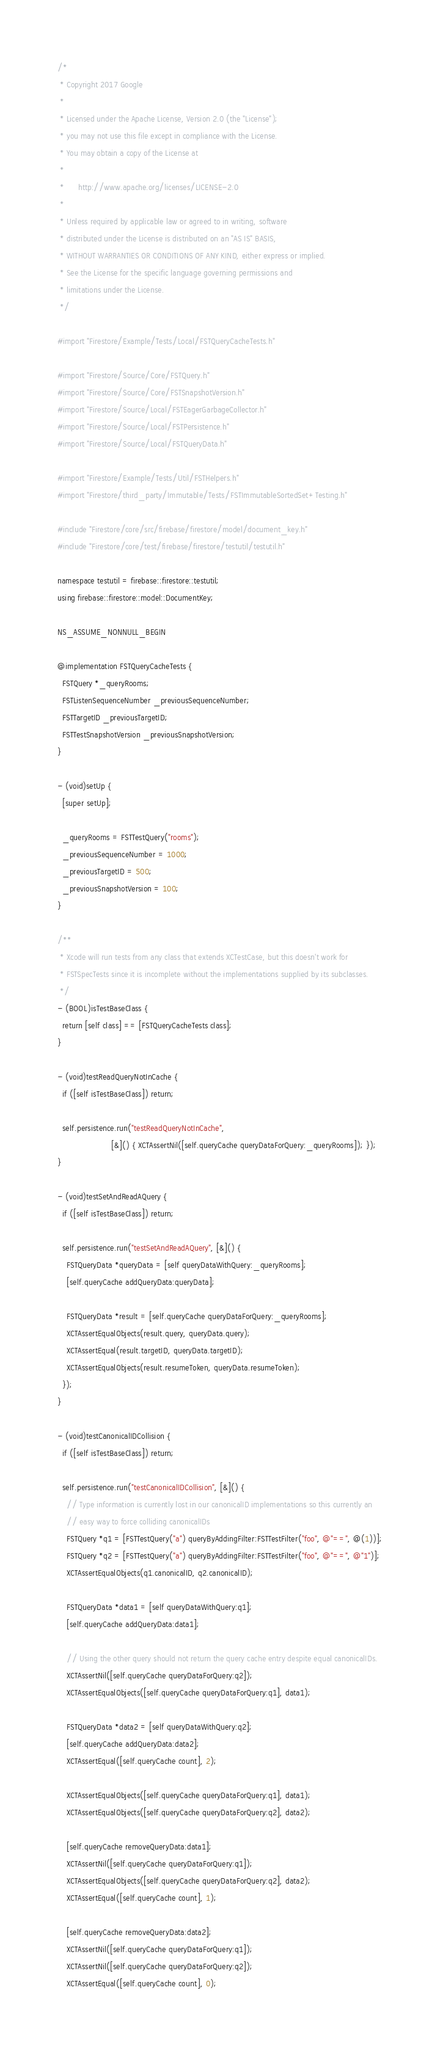Convert code to text. <code><loc_0><loc_0><loc_500><loc_500><_ObjectiveC_>/*
 * Copyright 2017 Google
 *
 * Licensed under the Apache License, Version 2.0 (the "License");
 * you may not use this file except in compliance with the License.
 * You may obtain a copy of the License at
 *
 *      http://www.apache.org/licenses/LICENSE-2.0
 *
 * Unless required by applicable law or agreed to in writing, software
 * distributed under the License is distributed on an "AS IS" BASIS,
 * WITHOUT WARRANTIES OR CONDITIONS OF ANY KIND, either express or implied.
 * See the License for the specific language governing permissions and
 * limitations under the License.
 */

#import "Firestore/Example/Tests/Local/FSTQueryCacheTests.h"

#import "Firestore/Source/Core/FSTQuery.h"
#import "Firestore/Source/Core/FSTSnapshotVersion.h"
#import "Firestore/Source/Local/FSTEagerGarbageCollector.h"
#import "Firestore/Source/Local/FSTPersistence.h"
#import "Firestore/Source/Local/FSTQueryData.h"

#import "Firestore/Example/Tests/Util/FSTHelpers.h"
#import "Firestore/third_party/Immutable/Tests/FSTImmutableSortedSet+Testing.h"

#include "Firestore/core/src/firebase/firestore/model/document_key.h"
#include "Firestore/core/test/firebase/firestore/testutil/testutil.h"

namespace testutil = firebase::firestore::testutil;
using firebase::firestore::model::DocumentKey;

NS_ASSUME_NONNULL_BEGIN

@implementation FSTQueryCacheTests {
  FSTQuery *_queryRooms;
  FSTListenSequenceNumber _previousSequenceNumber;
  FSTTargetID _previousTargetID;
  FSTTestSnapshotVersion _previousSnapshotVersion;
}

- (void)setUp {
  [super setUp];

  _queryRooms = FSTTestQuery("rooms");
  _previousSequenceNumber = 1000;
  _previousTargetID = 500;
  _previousSnapshotVersion = 100;
}

/**
 * Xcode will run tests from any class that extends XCTestCase, but this doesn't work for
 * FSTSpecTests since it is incomplete without the implementations supplied by its subclasses.
 */
- (BOOL)isTestBaseClass {
  return [self class] == [FSTQueryCacheTests class];
}

- (void)testReadQueryNotInCache {
  if ([self isTestBaseClass]) return;

  self.persistence.run("testReadQueryNotInCache",
                       [&]() { XCTAssertNil([self.queryCache queryDataForQuery:_queryRooms]); });
}

- (void)testSetAndReadAQuery {
  if ([self isTestBaseClass]) return;

  self.persistence.run("testSetAndReadAQuery", [&]() {
    FSTQueryData *queryData = [self queryDataWithQuery:_queryRooms];
    [self.queryCache addQueryData:queryData];

    FSTQueryData *result = [self.queryCache queryDataForQuery:_queryRooms];
    XCTAssertEqualObjects(result.query, queryData.query);
    XCTAssertEqual(result.targetID, queryData.targetID);
    XCTAssertEqualObjects(result.resumeToken, queryData.resumeToken);
  });
}

- (void)testCanonicalIDCollision {
  if ([self isTestBaseClass]) return;

  self.persistence.run("testCanonicalIDCollision", [&]() {
    // Type information is currently lost in our canonicalID implementations so this currently an
    // easy way to force colliding canonicalIDs
    FSTQuery *q1 = [FSTTestQuery("a") queryByAddingFilter:FSTTestFilter("foo", @"==", @(1))];
    FSTQuery *q2 = [FSTTestQuery("a") queryByAddingFilter:FSTTestFilter("foo", @"==", @"1")];
    XCTAssertEqualObjects(q1.canonicalID, q2.canonicalID);

    FSTQueryData *data1 = [self queryDataWithQuery:q1];
    [self.queryCache addQueryData:data1];

    // Using the other query should not return the query cache entry despite equal canonicalIDs.
    XCTAssertNil([self.queryCache queryDataForQuery:q2]);
    XCTAssertEqualObjects([self.queryCache queryDataForQuery:q1], data1);

    FSTQueryData *data2 = [self queryDataWithQuery:q2];
    [self.queryCache addQueryData:data2];
    XCTAssertEqual([self.queryCache count], 2);

    XCTAssertEqualObjects([self.queryCache queryDataForQuery:q1], data1);
    XCTAssertEqualObjects([self.queryCache queryDataForQuery:q2], data2);

    [self.queryCache removeQueryData:data1];
    XCTAssertNil([self.queryCache queryDataForQuery:q1]);
    XCTAssertEqualObjects([self.queryCache queryDataForQuery:q2], data2);
    XCTAssertEqual([self.queryCache count], 1);

    [self.queryCache removeQueryData:data2];
    XCTAssertNil([self.queryCache queryDataForQuery:q1]);
    XCTAssertNil([self.queryCache queryDataForQuery:q2]);
    XCTAssertEqual([self.queryCache count], 0);</code> 